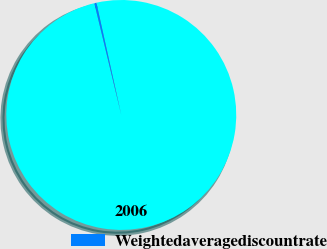<chart> <loc_0><loc_0><loc_500><loc_500><pie_chart><fcel>2006<fcel>Weightedaveragediscountrate<nl><fcel>99.71%<fcel>0.29%<nl></chart> 